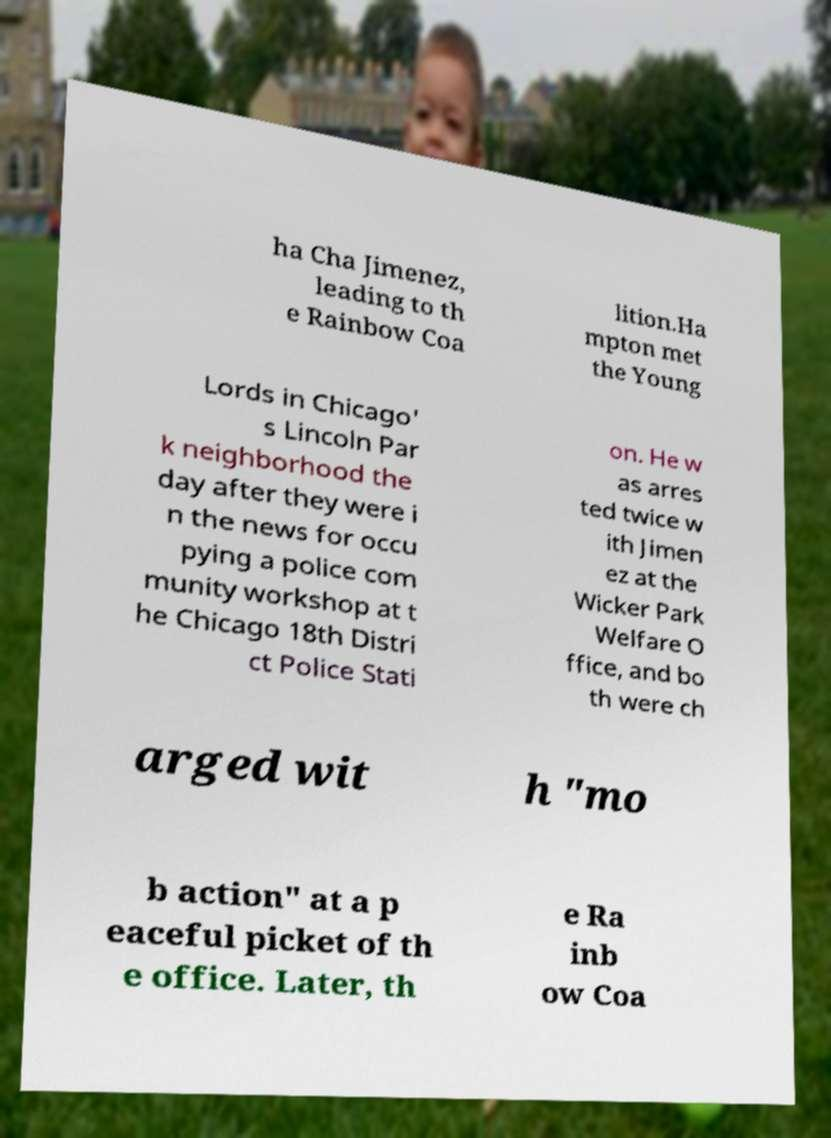What messages or text are displayed in this image? I need them in a readable, typed format. ha Cha Jimenez, leading to th e Rainbow Coa lition.Ha mpton met the Young Lords in Chicago' s Lincoln Par k neighborhood the day after they were i n the news for occu pying a police com munity workshop at t he Chicago 18th Distri ct Police Stati on. He w as arres ted twice w ith Jimen ez at the Wicker Park Welfare O ffice, and bo th were ch arged wit h "mo b action" at a p eaceful picket of th e office. Later, th e Ra inb ow Coa 